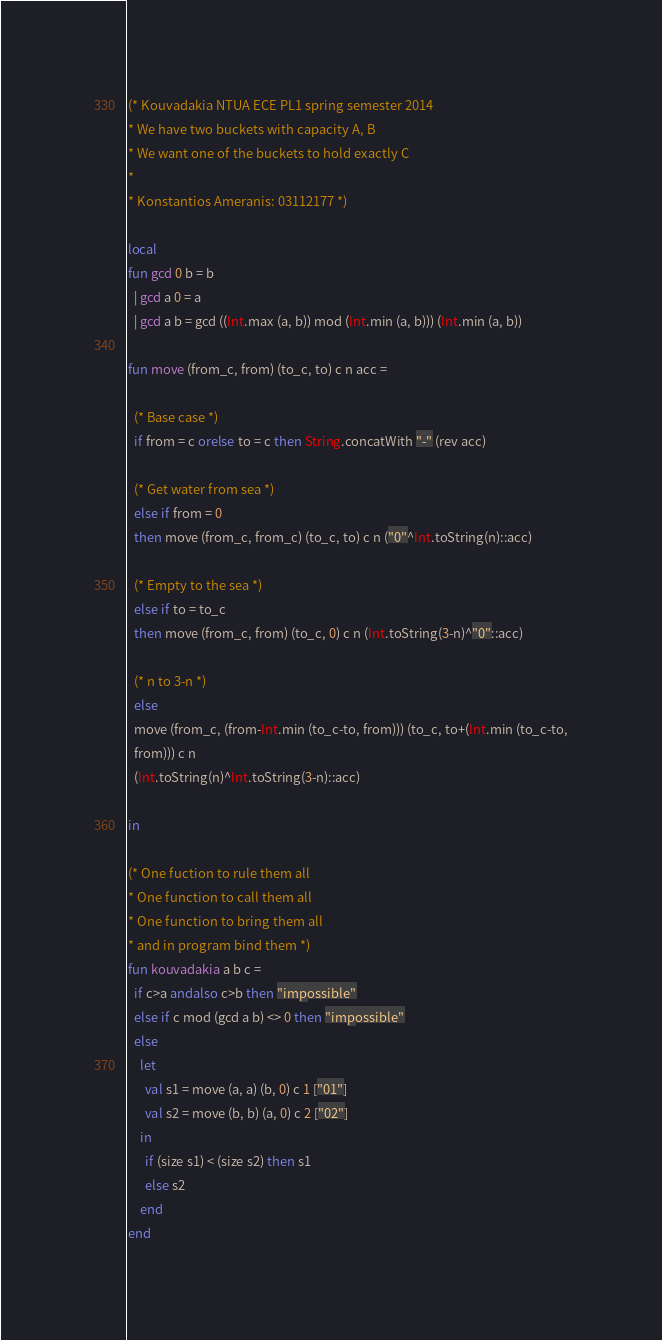<code> <loc_0><loc_0><loc_500><loc_500><_SML_>(* Kouvadakia NTUA ECE PL1 spring semester 2014
* We have two buckets with capacity A, B
* We want one of the buckets to hold exactly C
*
* Konstantios Ameranis: 03112177 *)

local
fun gcd 0 b = b
  | gcd a 0 = a
  | gcd a b = gcd ((Int.max (a, b)) mod (Int.min (a, b))) (Int.min (a, b))

fun move (from_c, from) (to_c, to) c n acc =
  
  (* Base case *)
  if from = c orelse to = c then String.concatWith "-" (rev acc)
  
  (* Get water from sea *)
  else if from = 0
  then move (from_c, from_c) (to_c, to) c n ("0"^Int.toString(n)::acc)
  
  (* Empty to the sea *)
  else if to = to_c
  then move (from_c, from) (to_c, 0) c n (Int.toString(3-n)^"0"::acc)
  
  (* n to 3-n *)
  else
  move (from_c, (from-Int.min (to_c-to, from))) (to_c, to+(Int.min (to_c-to,
  from))) c n
  (Int.toString(n)^Int.toString(3-n)::acc)

in

(* One fuction to rule them all
* One function to call them all
* One function to bring them all
* and in program bind them *)
fun kouvadakia a b c =
  if c>a andalso c>b then "impossible"
  else if c mod (gcd a b) <> 0 then "impossible"
  else 
    let
      val s1 = move (a, a) (b, 0) c 1 ["01"]
      val s2 = move (b, b) (a, 0) c 2 ["02"]
    in
      if (size s1) < (size s2) then s1
      else s2
    end
end
</code> 